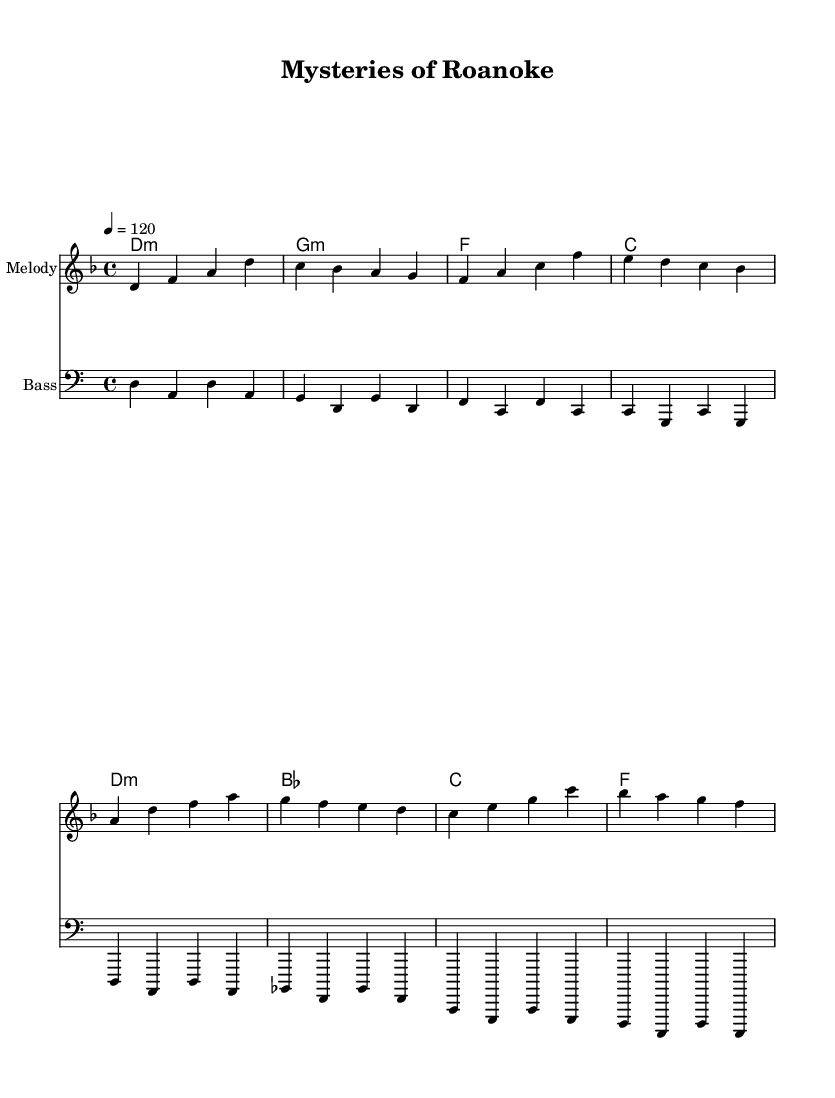What is the key signature of this music? The key signature is D minor, which typically has one flat (B flat). This can be determined by looking at the "key" indicated in the global section of the code, which specifies "d \minor."
Answer: D minor What is the time signature of this music? The time signature is 4/4, also known as common time. This is indicated in the global section where it states "\time 4/4."
Answer: 4/4 What is the tempo marking given in the music? The tempo marking is 120 beats per minute. This is indicated in the global section with the notation "\tempo 4 = 120."
Answer: 120 What is the first note of the melody? The first note of the melody is D. In the melody section, it begins with "d4," where "d" represents the pitch and "4" denotes the note's duration.
Answer: D What is the harmonic structure of the piece? The harmonic structure consists of the chords: D minor, G minor, F, and C. This can be discerned from the harmonies section, where each chord begins a measure and is listed sequentially.
Answer: D minor, G minor, F, C How does the bass line relate to the melody? The bass line primarily outlines the root notes of the chords, supporting the harmony and providing a bass foundation for the melody. Each note in the bass line corresponds with the chord being played, enhancing the harmonic progression.
Answer: Root notes of chords 